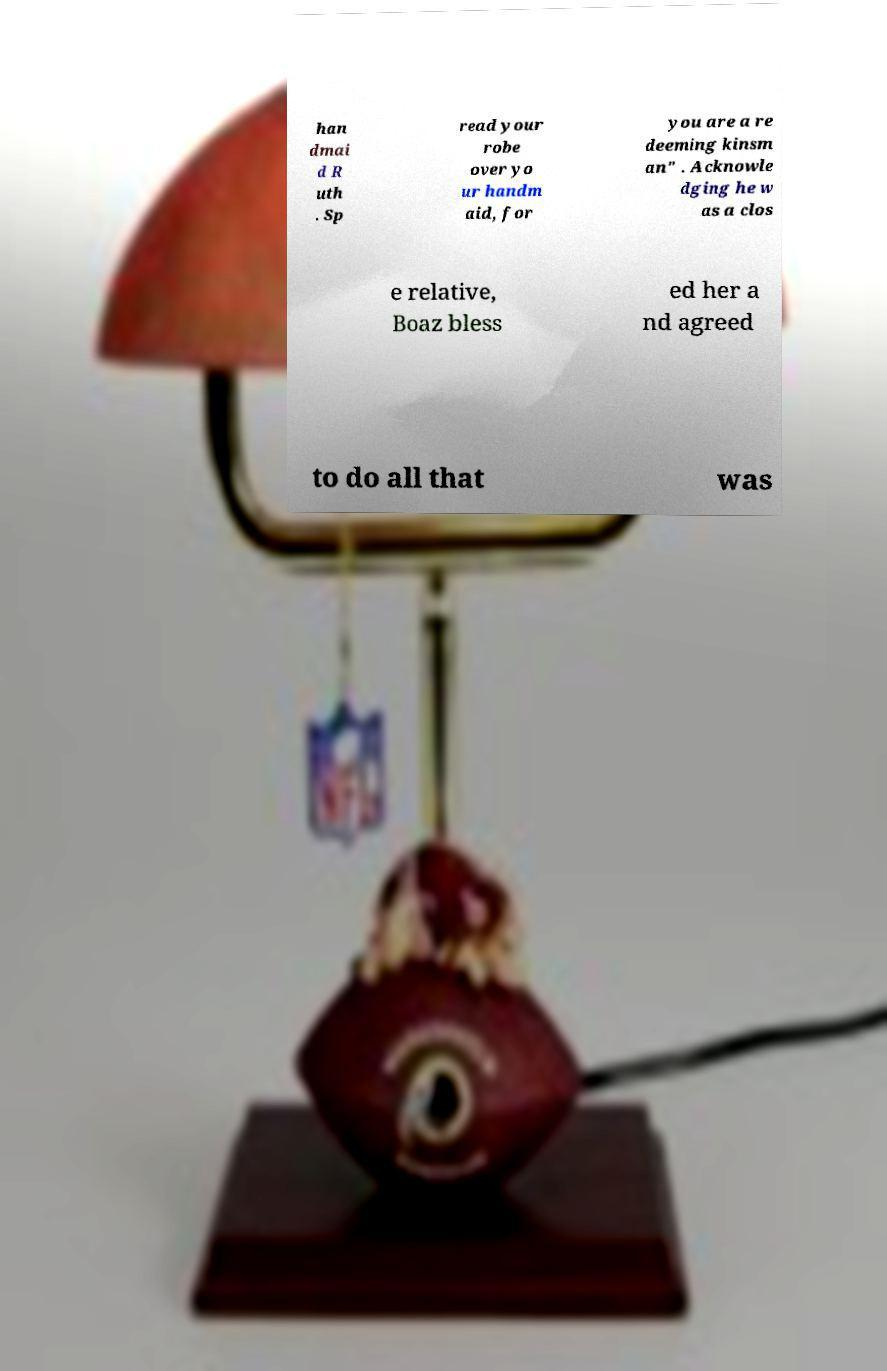What messages or text are displayed in this image? I need them in a readable, typed format. han dmai d R uth . Sp read your robe over yo ur handm aid, for you are a re deeming kinsm an" . Acknowle dging he w as a clos e relative, Boaz bless ed her a nd agreed to do all that was 